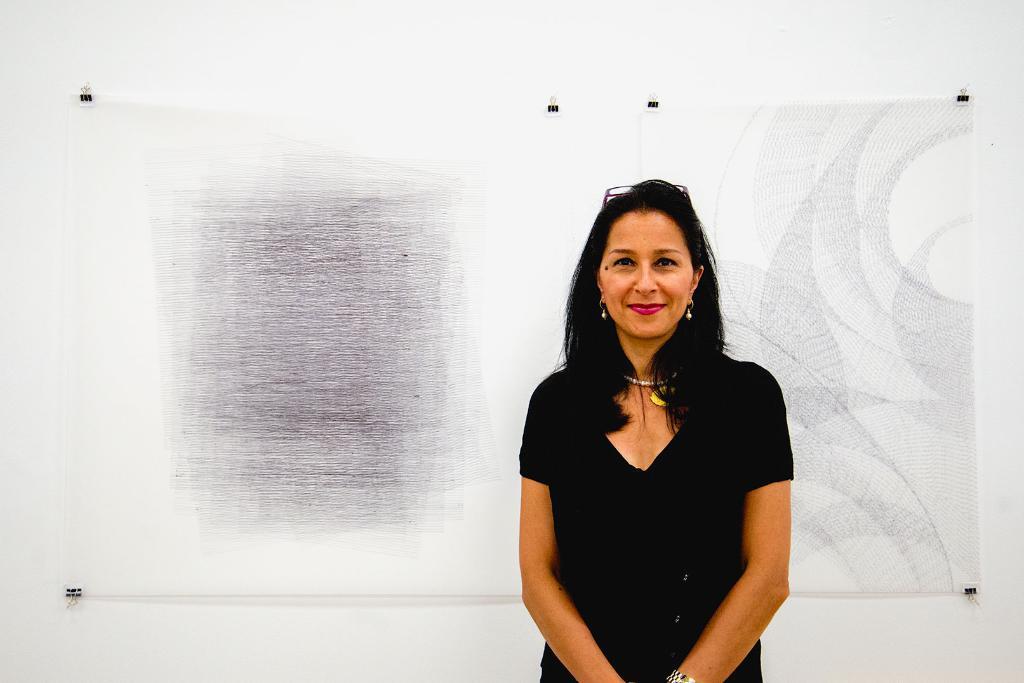How would you summarize this image in a sentence or two? On the right side, there is a woman in a black color dress, smiling and standing. In the background, there is a painting which is attached to the white wall. 